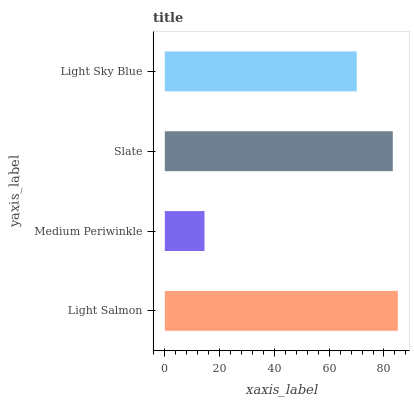Is Medium Periwinkle the minimum?
Answer yes or no. Yes. Is Light Salmon the maximum?
Answer yes or no. Yes. Is Slate the minimum?
Answer yes or no. No. Is Slate the maximum?
Answer yes or no. No. Is Slate greater than Medium Periwinkle?
Answer yes or no. Yes. Is Medium Periwinkle less than Slate?
Answer yes or no. Yes. Is Medium Periwinkle greater than Slate?
Answer yes or no. No. Is Slate less than Medium Periwinkle?
Answer yes or no. No. Is Slate the high median?
Answer yes or no. Yes. Is Light Sky Blue the low median?
Answer yes or no. Yes. Is Light Sky Blue the high median?
Answer yes or no. No. Is Slate the low median?
Answer yes or no. No. 